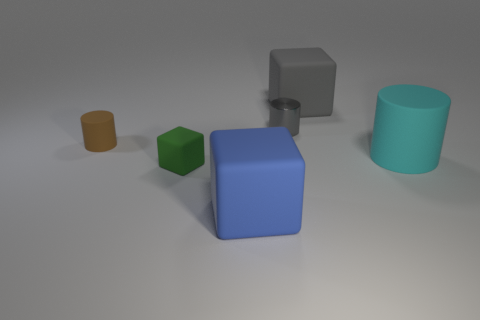Subtract all matte cylinders. How many cylinders are left? 1 Add 3 cylinders. How many objects exist? 9 Subtract all gray cubes. How many cubes are left? 2 Subtract 1 blocks. How many blocks are left? 2 Subtract all yellow cubes. Subtract all blue balls. How many cubes are left? 3 Subtract all cyan cubes. How many green cylinders are left? 0 Subtract all blue blocks. Subtract all big blue rubber things. How many objects are left? 4 Add 3 small matte cylinders. How many small matte cylinders are left? 4 Add 4 big cyan cylinders. How many big cyan cylinders exist? 5 Subtract 0 blue cylinders. How many objects are left? 6 